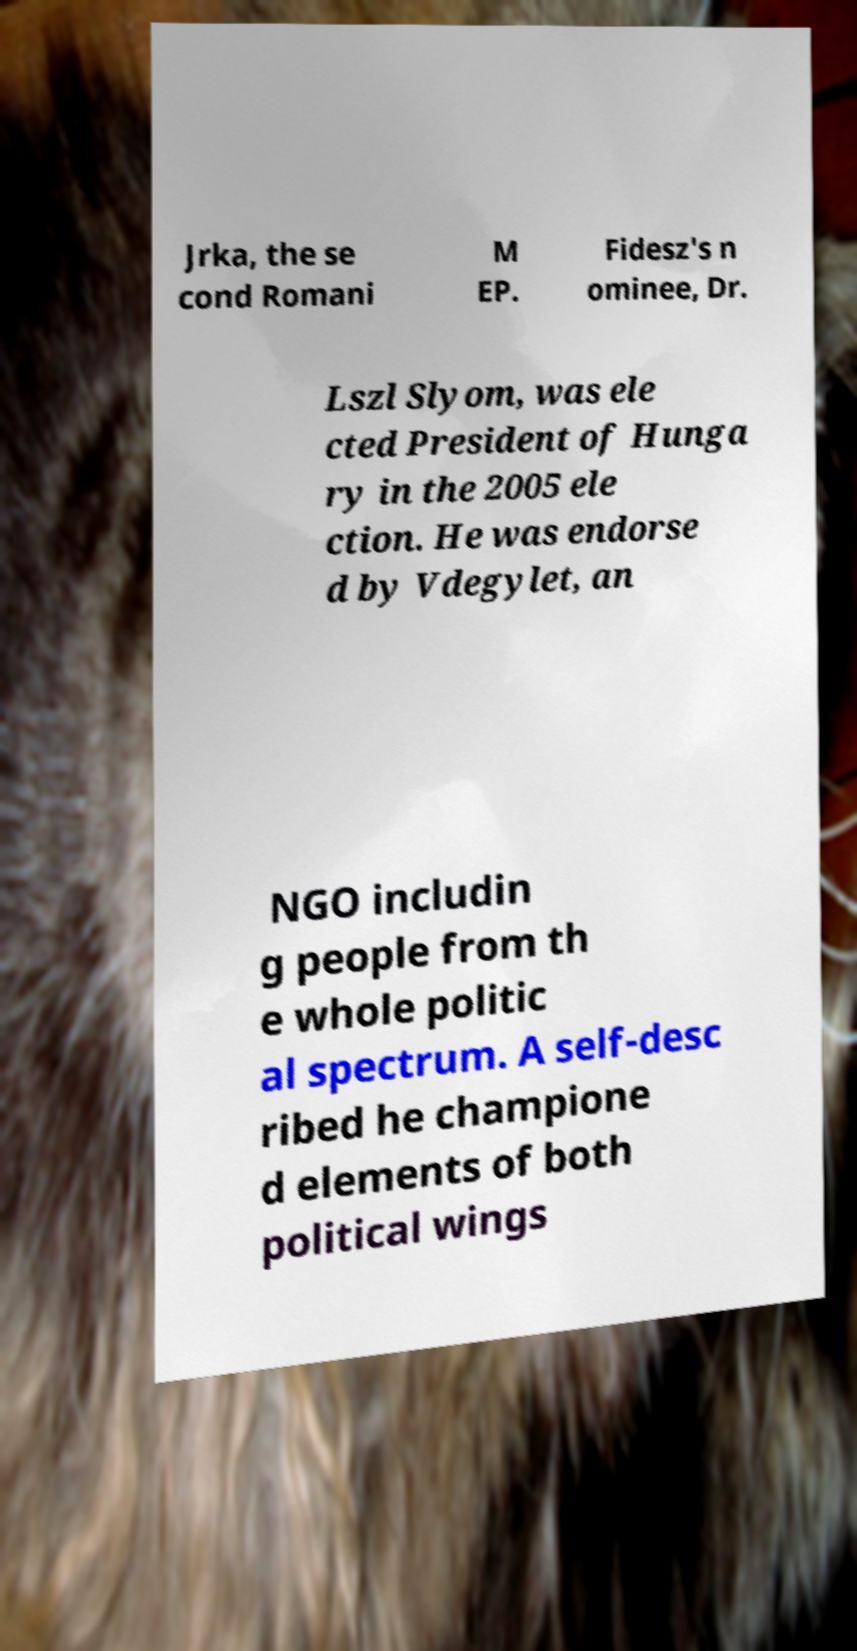Please read and relay the text visible in this image. What does it say? Jrka, the se cond Romani M EP. Fidesz's n ominee, Dr. Lszl Slyom, was ele cted President of Hunga ry in the 2005 ele ction. He was endorse d by Vdegylet, an NGO includin g people from th e whole politic al spectrum. A self-desc ribed he champione d elements of both political wings 